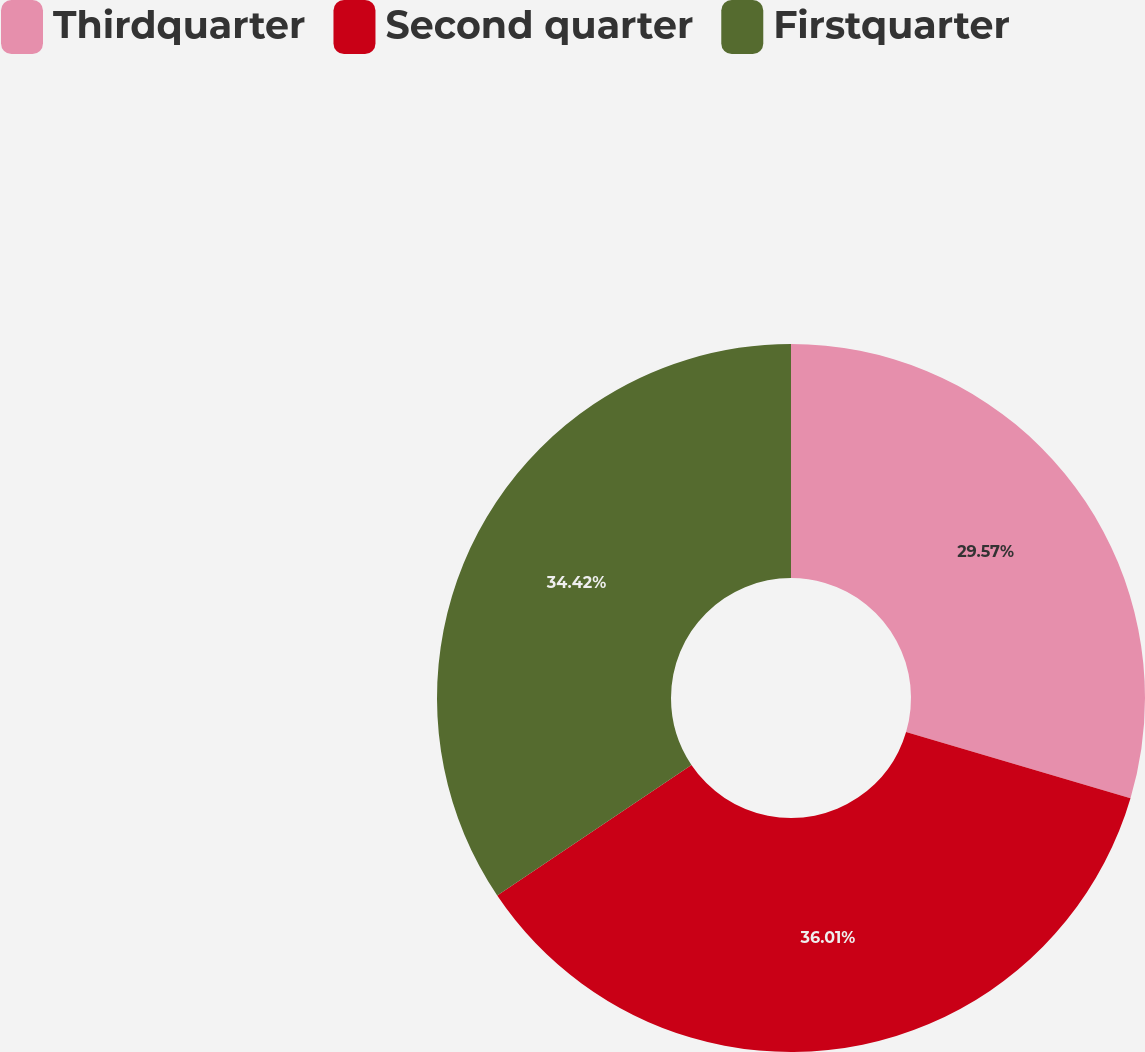Convert chart. <chart><loc_0><loc_0><loc_500><loc_500><pie_chart><fcel>Thirdquarter<fcel>Second quarter<fcel>Firstquarter<nl><fcel>29.57%<fcel>36.01%<fcel>34.42%<nl></chart> 